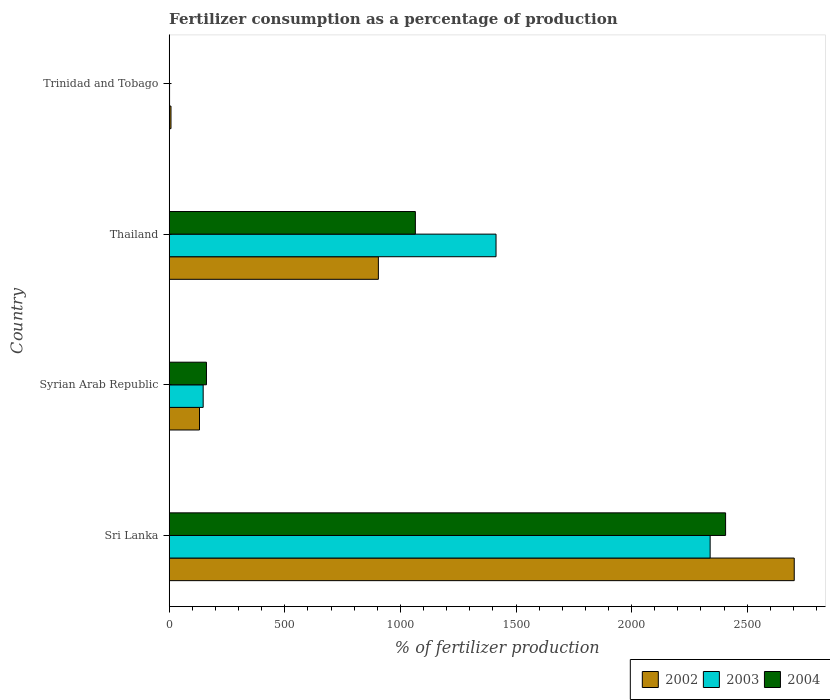Are the number of bars on each tick of the Y-axis equal?
Your answer should be compact. Yes. How many bars are there on the 2nd tick from the top?
Provide a short and direct response. 3. What is the label of the 1st group of bars from the top?
Offer a terse response. Trinidad and Tobago. In how many cases, is the number of bars for a given country not equal to the number of legend labels?
Provide a short and direct response. 0. What is the percentage of fertilizers consumed in 2002 in Trinidad and Tobago?
Give a very brief answer. 7.7. Across all countries, what is the maximum percentage of fertilizers consumed in 2004?
Your answer should be compact. 2406.46. Across all countries, what is the minimum percentage of fertilizers consumed in 2003?
Offer a very short reply. 1.52. In which country was the percentage of fertilizers consumed in 2003 maximum?
Provide a short and direct response. Sri Lanka. In which country was the percentage of fertilizers consumed in 2003 minimum?
Ensure brevity in your answer.  Trinidad and Tobago. What is the total percentage of fertilizers consumed in 2003 in the graph?
Ensure brevity in your answer.  3901.64. What is the difference between the percentage of fertilizers consumed in 2002 in Syrian Arab Republic and that in Trinidad and Tobago?
Make the answer very short. 123.32. What is the difference between the percentage of fertilizers consumed in 2004 in Thailand and the percentage of fertilizers consumed in 2003 in Syrian Arab Republic?
Provide a short and direct response. 917.73. What is the average percentage of fertilizers consumed in 2004 per country?
Give a very brief answer. 908.26. What is the difference between the percentage of fertilizers consumed in 2003 and percentage of fertilizers consumed in 2004 in Syrian Arab Republic?
Your response must be concise. -14.18. What is the ratio of the percentage of fertilizers consumed in 2003 in Thailand to that in Trinidad and Tobago?
Your answer should be very brief. 931.21. What is the difference between the highest and the second highest percentage of fertilizers consumed in 2003?
Ensure brevity in your answer.  926.08. What is the difference between the highest and the lowest percentage of fertilizers consumed in 2003?
Your response must be concise. 2338.13. In how many countries, is the percentage of fertilizers consumed in 2003 greater than the average percentage of fertilizers consumed in 2003 taken over all countries?
Make the answer very short. 2. Is the sum of the percentage of fertilizers consumed in 2003 in Syrian Arab Republic and Trinidad and Tobago greater than the maximum percentage of fertilizers consumed in 2002 across all countries?
Provide a short and direct response. No. What does the 2nd bar from the bottom in Syrian Arab Republic represents?
Keep it short and to the point. 2003. How many bars are there?
Provide a short and direct response. 12. Does the graph contain grids?
Make the answer very short. No. How many legend labels are there?
Provide a short and direct response. 3. What is the title of the graph?
Your answer should be compact. Fertilizer consumption as a percentage of production. Does "1968" appear as one of the legend labels in the graph?
Provide a succinct answer. No. What is the label or title of the X-axis?
Provide a succinct answer. % of fertilizer production. What is the label or title of the Y-axis?
Make the answer very short. Country. What is the % of fertilizer production in 2002 in Sri Lanka?
Keep it short and to the point. 2703.38. What is the % of fertilizer production in 2003 in Sri Lanka?
Make the answer very short. 2339.65. What is the % of fertilizer production in 2004 in Sri Lanka?
Give a very brief answer. 2406.46. What is the % of fertilizer production in 2002 in Syrian Arab Republic?
Ensure brevity in your answer.  131.02. What is the % of fertilizer production of 2003 in Syrian Arab Republic?
Provide a succinct answer. 146.9. What is the % of fertilizer production of 2004 in Syrian Arab Republic?
Your answer should be compact. 161.07. What is the % of fertilizer production in 2002 in Thailand?
Your answer should be compact. 904.7. What is the % of fertilizer production of 2003 in Thailand?
Offer a terse response. 1413.57. What is the % of fertilizer production of 2004 in Thailand?
Your answer should be compact. 1064.63. What is the % of fertilizer production of 2002 in Trinidad and Tobago?
Give a very brief answer. 7.7. What is the % of fertilizer production of 2003 in Trinidad and Tobago?
Your answer should be very brief. 1.52. What is the % of fertilizer production of 2004 in Trinidad and Tobago?
Your answer should be compact. 0.88. Across all countries, what is the maximum % of fertilizer production of 2002?
Make the answer very short. 2703.38. Across all countries, what is the maximum % of fertilizer production in 2003?
Your answer should be very brief. 2339.65. Across all countries, what is the maximum % of fertilizer production of 2004?
Your response must be concise. 2406.46. Across all countries, what is the minimum % of fertilizer production of 2002?
Offer a very short reply. 7.7. Across all countries, what is the minimum % of fertilizer production of 2003?
Give a very brief answer. 1.52. Across all countries, what is the minimum % of fertilizer production in 2004?
Ensure brevity in your answer.  0.88. What is the total % of fertilizer production in 2002 in the graph?
Make the answer very short. 3746.79. What is the total % of fertilizer production of 2003 in the graph?
Keep it short and to the point. 3901.64. What is the total % of fertilizer production of 2004 in the graph?
Your answer should be very brief. 3633.04. What is the difference between the % of fertilizer production of 2002 in Sri Lanka and that in Syrian Arab Republic?
Offer a very short reply. 2572.36. What is the difference between the % of fertilizer production of 2003 in Sri Lanka and that in Syrian Arab Republic?
Your response must be concise. 2192.76. What is the difference between the % of fertilizer production in 2004 in Sri Lanka and that in Syrian Arab Republic?
Your response must be concise. 2245.38. What is the difference between the % of fertilizer production of 2002 in Sri Lanka and that in Thailand?
Offer a very short reply. 1798.68. What is the difference between the % of fertilizer production in 2003 in Sri Lanka and that in Thailand?
Provide a short and direct response. 926.08. What is the difference between the % of fertilizer production of 2004 in Sri Lanka and that in Thailand?
Your response must be concise. 1341.83. What is the difference between the % of fertilizer production in 2002 in Sri Lanka and that in Trinidad and Tobago?
Your response must be concise. 2695.68. What is the difference between the % of fertilizer production of 2003 in Sri Lanka and that in Trinidad and Tobago?
Make the answer very short. 2338.13. What is the difference between the % of fertilizer production of 2004 in Sri Lanka and that in Trinidad and Tobago?
Provide a succinct answer. 2405.58. What is the difference between the % of fertilizer production in 2002 in Syrian Arab Republic and that in Thailand?
Ensure brevity in your answer.  -773.68. What is the difference between the % of fertilizer production of 2003 in Syrian Arab Republic and that in Thailand?
Your answer should be very brief. -1266.68. What is the difference between the % of fertilizer production of 2004 in Syrian Arab Republic and that in Thailand?
Ensure brevity in your answer.  -903.55. What is the difference between the % of fertilizer production in 2002 in Syrian Arab Republic and that in Trinidad and Tobago?
Give a very brief answer. 123.32. What is the difference between the % of fertilizer production in 2003 in Syrian Arab Republic and that in Trinidad and Tobago?
Provide a short and direct response. 145.38. What is the difference between the % of fertilizer production in 2004 in Syrian Arab Republic and that in Trinidad and Tobago?
Offer a terse response. 160.2. What is the difference between the % of fertilizer production in 2002 in Thailand and that in Trinidad and Tobago?
Your answer should be compact. 897. What is the difference between the % of fertilizer production in 2003 in Thailand and that in Trinidad and Tobago?
Your answer should be very brief. 1412.06. What is the difference between the % of fertilizer production of 2004 in Thailand and that in Trinidad and Tobago?
Provide a short and direct response. 1063.75. What is the difference between the % of fertilizer production in 2002 in Sri Lanka and the % of fertilizer production in 2003 in Syrian Arab Republic?
Offer a very short reply. 2556.48. What is the difference between the % of fertilizer production in 2002 in Sri Lanka and the % of fertilizer production in 2004 in Syrian Arab Republic?
Give a very brief answer. 2542.3. What is the difference between the % of fertilizer production of 2003 in Sri Lanka and the % of fertilizer production of 2004 in Syrian Arab Republic?
Your answer should be compact. 2178.58. What is the difference between the % of fertilizer production in 2002 in Sri Lanka and the % of fertilizer production in 2003 in Thailand?
Keep it short and to the point. 1289.8. What is the difference between the % of fertilizer production in 2002 in Sri Lanka and the % of fertilizer production in 2004 in Thailand?
Your answer should be very brief. 1638.75. What is the difference between the % of fertilizer production in 2003 in Sri Lanka and the % of fertilizer production in 2004 in Thailand?
Offer a very short reply. 1275.02. What is the difference between the % of fertilizer production of 2002 in Sri Lanka and the % of fertilizer production of 2003 in Trinidad and Tobago?
Your answer should be very brief. 2701.86. What is the difference between the % of fertilizer production in 2002 in Sri Lanka and the % of fertilizer production in 2004 in Trinidad and Tobago?
Provide a short and direct response. 2702.5. What is the difference between the % of fertilizer production of 2003 in Sri Lanka and the % of fertilizer production of 2004 in Trinidad and Tobago?
Your answer should be compact. 2338.77. What is the difference between the % of fertilizer production in 2002 in Syrian Arab Republic and the % of fertilizer production in 2003 in Thailand?
Offer a terse response. -1282.56. What is the difference between the % of fertilizer production of 2002 in Syrian Arab Republic and the % of fertilizer production of 2004 in Thailand?
Your answer should be compact. -933.61. What is the difference between the % of fertilizer production in 2003 in Syrian Arab Republic and the % of fertilizer production in 2004 in Thailand?
Your response must be concise. -917.73. What is the difference between the % of fertilizer production in 2002 in Syrian Arab Republic and the % of fertilizer production in 2003 in Trinidad and Tobago?
Keep it short and to the point. 129.5. What is the difference between the % of fertilizer production of 2002 in Syrian Arab Republic and the % of fertilizer production of 2004 in Trinidad and Tobago?
Offer a terse response. 130.14. What is the difference between the % of fertilizer production of 2003 in Syrian Arab Republic and the % of fertilizer production of 2004 in Trinidad and Tobago?
Your answer should be very brief. 146.02. What is the difference between the % of fertilizer production in 2002 in Thailand and the % of fertilizer production in 2003 in Trinidad and Tobago?
Offer a very short reply. 903.18. What is the difference between the % of fertilizer production of 2002 in Thailand and the % of fertilizer production of 2004 in Trinidad and Tobago?
Your answer should be very brief. 903.82. What is the difference between the % of fertilizer production of 2003 in Thailand and the % of fertilizer production of 2004 in Trinidad and Tobago?
Provide a short and direct response. 1412.7. What is the average % of fertilizer production in 2002 per country?
Give a very brief answer. 936.7. What is the average % of fertilizer production in 2003 per country?
Provide a succinct answer. 975.41. What is the average % of fertilizer production of 2004 per country?
Ensure brevity in your answer.  908.26. What is the difference between the % of fertilizer production in 2002 and % of fertilizer production in 2003 in Sri Lanka?
Ensure brevity in your answer.  363.72. What is the difference between the % of fertilizer production in 2002 and % of fertilizer production in 2004 in Sri Lanka?
Your answer should be very brief. 296.92. What is the difference between the % of fertilizer production of 2003 and % of fertilizer production of 2004 in Sri Lanka?
Offer a very short reply. -66.8. What is the difference between the % of fertilizer production in 2002 and % of fertilizer production in 2003 in Syrian Arab Republic?
Your answer should be very brief. -15.88. What is the difference between the % of fertilizer production of 2002 and % of fertilizer production of 2004 in Syrian Arab Republic?
Make the answer very short. -30.06. What is the difference between the % of fertilizer production in 2003 and % of fertilizer production in 2004 in Syrian Arab Republic?
Your response must be concise. -14.18. What is the difference between the % of fertilizer production in 2002 and % of fertilizer production in 2003 in Thailand?
Offer a terse response. -508.88. What is the difference between the % of fertilizer production of 2002 and % of fertilizer production of 2004 in Thailand?
Provide a short and direct response. -159.93. What is the difference between the % of fertilizer production of 2003 and % of fertilizer production of 2004 in Thailand?
Provide a short and direct response. 348.95. What is the difference between the % of fertilizer production of 2002 and % of fertilizer production of 2003 in Trinidad and Tobago?
Offer a very short reply. 6.18. What is the difference between the % of fertilizer production in 2002 and % of fertilizer production in 2004 in Trinidad and Tobago?
Offer a terse response. 6.82. What is the difference between the % of fertilizer production of 2003 and % of fertilizer production of 2004 in Trinidad and Tobago?
Ensure brevity in your answer.  0.64. What is the ratio of the % of fertilizer production in 2002 in Sri Lanka to that in Syrian Arab Republic?
Offer a very short reply. 20.63. What is the ratio of the % of fertilizer production of 2003 in Sri Lanka to that in Syrian Arab Republic?
Your response must be concise. 15.93. What is the ratio of the % of fertilizer production of 2004 in Sri Lanka to that in Syrian Arab Republic?
Your answer should be very brief. 14.94. What is the ratio of the % of fertilizer production of 2002 in Sri Lanka to that in Thailand?
Provide a succinct answer. 2.99. What is the ratio of the % of fertilizer production in 2003 in Sri Lanka to that in Thailand?
Offer a terse response. 1.66. What is the ratio of the % of fertilizer production of 2004 in Sri Lanka to that in Thailand?
Keep it short and to the point. 2.26. What is the ratio of the % of fertilizer production in 2002 in Sri Lanka to that in Trinidad and Tobago?
Keep it short and to the point. 351.14. What is the ratio of the % of fertilizer production of 2003 in Sri Lanka to that in Trinidad and Tobago?
Provide a succinct answer. 1541.27. What is the ratio of the % of fertilizer production of 2004 in Sri Lanka to that in Trinidad and Tobago?
Give a very brief answer. 2741.28. What is the ratio of the % of fertilizer production in 2002 in Syrian Arab Republic to that in Thailand?
Give a very brief answer. 0.14. What is the ratio of the % of fertilizer production in 2003 in Syrian Arab Republic to that in Thailand?
Your answer should be very brief. 0.1. What is the ratio of the % of fertilizer production in 2004 in Syrian Arab Republic to that in Thailand?
Your answer should be very brief. 0.15. What is the ratio of the % of fertilizer production in 2002 in Syrian Arab Republic to that in Trinidad and Tobago?
Ensure brevity in your answer.  17.02. What is the ratio of the % of fertilizer production in 2003 in Syrian Arab Republic to that in Trinidad and Tobago?
Your answer should be very brief. 96.77. What is the ratio of the % of fertilizer production of 2004 in Syrian Arab Republic to that in Trinidad and Tobago?
Your answer should be compact. 183.49. What is the ratio of the % of fertilizer production in 2002 in Thailand to that in Trinidad and Tobago?
Provide a succinct answer. 117.51. What is the ratio of the % of fertilizer production in 2003 in Thailand to that in Trinidad and Tobago?
Your answer should be very brief. 931.21. What is the ratio of the % of fertilizer production of 2004 in Thailand to that in Trinidad and Tobago?
Your response must be concise. 1212.76. What is the difference between the highest and the second highest % of fertilizer production of 2002?
Your answer should be compact. 1798.68. What is the difference between the highest and the second highest % of fertilizer production of 2003?
Give a very brief answer. 926.08. What is the difference between the highest and the second highest % of fertilizer production in 2004?
Ensure brevity in your answer.  1341.83. What is the difference between the highest and the lowest % of fertilizer production in 2002?
Offer a very short reply. 2695.68. What is the difference between the highest and the lowest % of fertilizer production of 2003?
Your response must be concise. 2338.13. What is the difference between the highest and the lowest % of fertilizer production in 2004?
Offer a very short reply. 2405.58. 